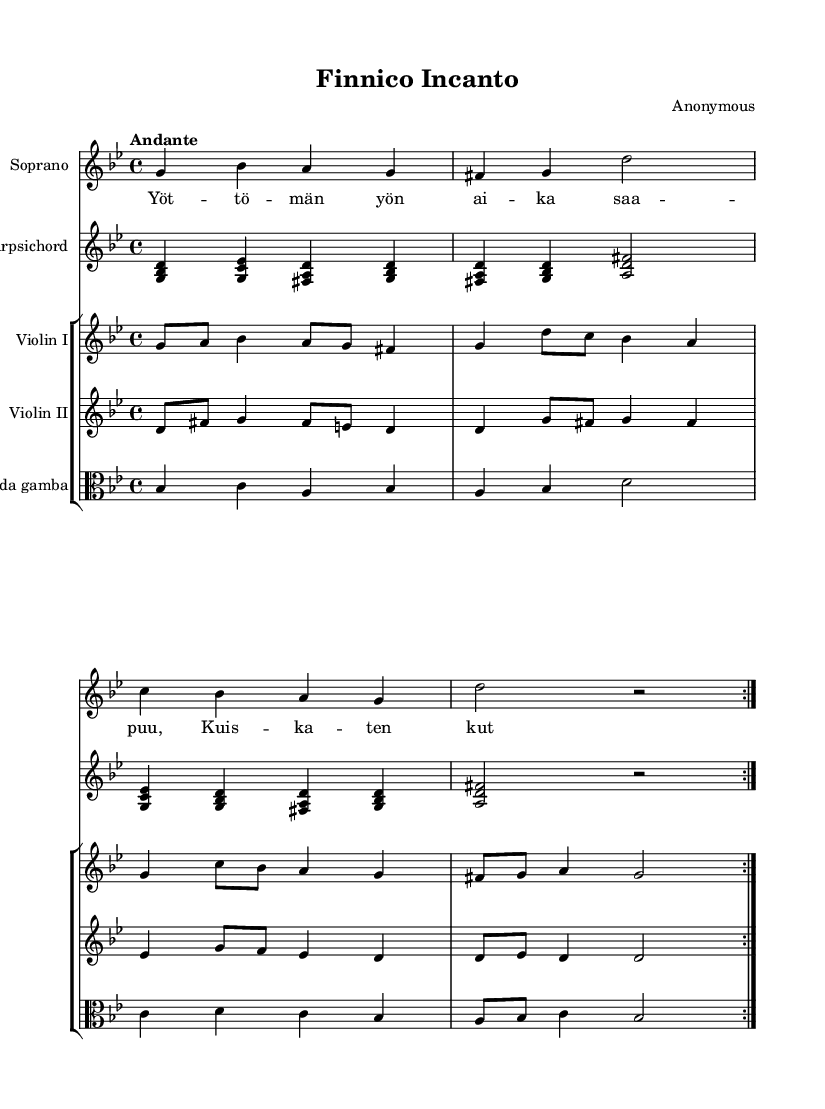What is the key signature of this music? The key signature is indicated by the number of sharps or flats at the beginning of the staff. In this case, we see two flats, which corresponds to G minor.
Answer: G minor What is the time signature of this music? The time signature is shown as a fraction at the beginning of the piece. Here, it is written as 4/4, indicating there are four beats per measure.
Answer: 4/4 What is the tempo marking of this piece? The tempo marking is written above the staff, indicating how fast or slow the music should be played. It says "Andante," which generally means a moderately slow tempo.
Answer: Andante How many measures are in the soprano part before the first repeat? Counting the measures in the soprano part leading up to the repeat sign (which indicates the end of the first section), there are four measures.
Answer: 4 What instruments are present in the score? The instruments are listed by their respective staff names. There’s a Soprano, Harpsichord, Violin I, Violin II, and Viola da gamba, which total five instruments.
Answer: Soprano, Harpsichord, Violin I, Violin II, Viola da gamba How many times is the section for the soprano repeated? The repeat sign in the soprano part shows that this section is intended to be played two times.
Answer: 2 What is the overall texture of the music as indicated by the instrumentation? The combination of instruments suggests a rich texture typical of Baroque music, featuring a solo voice (soprano) supported by a continuo (harpsichord) and two violins along with viola, creating a polyphonic texture.
Answer: Polyphonic 